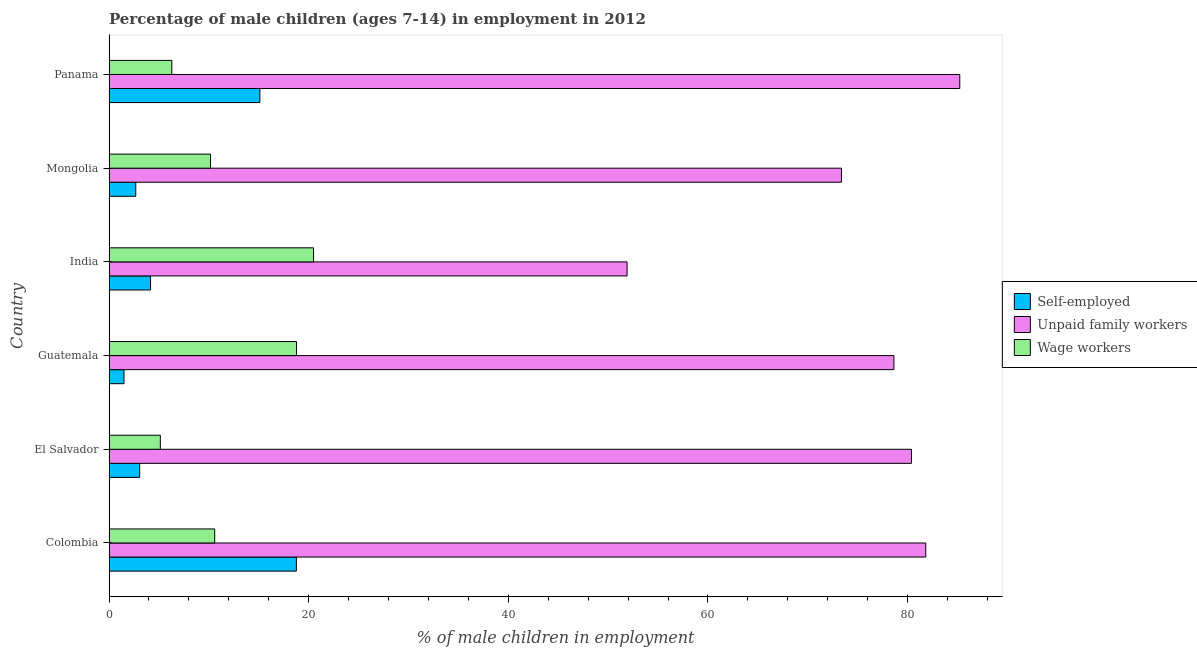How many groups of bars are there?
Provide a succinct answer. 6. Are the number of bars per tick equal to the number of legend labels?
Keep it short and to the point. Yes. How many bars are there on the 4th tick from the top?
Your response must be concise. 3. What is the percentage of children employed as wage workers in Guatemala?
Offer a terse response. 18.78. Across all countries, what is the maximum percentage of children employed as unpaid family workers?
Offer a terse response. 85.23. Across all countries, what is the minimum percentage of children employed as wage workers?
Make the answer very short. 5.14. In which country was the percentage of children employed as wage workers minimum?
Keep it short and to the point. El Salvador. What is the total percentage of children employed as wage workers in the graph?
Ensure brevity in your answer.  71.46. What is the difference between the percentage of children employed as unpaid family workers in Guatemala and that in India?
Your response must be concise. 26.73. What is the difference between the percentage of self employed children in Guatemala and the percentage of children employed as wage workers in India?
Offer a terse response. -18.99. What is the average percentage of children employed as wage workers per country?
Provide a succinct answer. 11.91. What is the difference between the percentage of children employed as unpaid family workers and percentage of self employed children in Panama?
Provide a succinct answer. 70.12. What is the ratio of the percentage of children employed as unpaid family workers in El Salvador to that in Panama?
Give a very brief answer. 0.94. Is the percentage of children employed as unpaid family workers in India less than that in Mongolia?
Provide a succinct answer. Yes. What is the difference between the highest and the second highest percentage of children employed as unpaid family workers?
Provide a short and direct response. 3.41. What is the difference between the highest and the lowest percentage of children employed as unpaid family workers?
Keep it short and to the point. 33.33. In how many countries, is the percentage of self employed children greater than the average percentage of self employed children taken over all countries?
Your response must be concise. 2. What does the 3rd bar from the top in Colombia represents?
Provide a short and direct response. Self-employed. What does the 1st bar from the bottom in Guatemala represents?
Provide a succinct answer. Self-employed. Is it the case that in every country, the sum of the percentage of self employed children and percentage of children employed as unpaid family workers is greater than the percentage of children employed as wage workers?
Ensure brevity in your answer.  Yes. How many bars are there?
Give a very brief answer. 18. What is the difference between two consecutive major ticks on the X-axis?
Offer a terse response. 20. Does the graph contain any zero values?
Provide a short and direct response. No. Where does the legend appear in the graph?
Provide a short and direct response. Center right. How many legend labels are there?
Your response must be concise. 3. What is the title of the graph?
Offer a terse response. Percentage of male children (ages 7-14) in employment in 2012. What is the label or title of the X-axis?
Give a very brief answer. % of male children in employment. What is the % of male children in employment of Self-employed in Colombia?
Your response must be concise. 18.77. What is the % of male children in employment in Unpaid family workers in Colombia?
Your answer should be very brief. 81.82. What is the % of male children in employment in Wage workers in Colombia?
Provide a short and direct response. 10.59. What is the % of male children in employment of Self-employed in El Salvador?
Your answer should be very brief. 3.07. What is the % of male children in employment of Unpaid family workers in El Salvador?
Provide a succinct answer. 80.39. What is the % of male children in employment in Wage workers in El Salvador?
Give a very brief answer. 5.14. What is the % of male children in employment of Self-employed in Guatemala?
Offer a very short reply. 1.5. What is the % of male children in employment of Unpaid family workers in Guatemala?
Ensure brevity in your answer.  78.63. What is the % of male children in employment of Wage workers in Guatemala?
Offer a terse response. 18.78. What is the % of male children in employment in Self-employed in India?
Offer a terse response. 4.16. What is the % of male children in employment of Unpaid family workers in India?
Provide a succinct answer. 51.9. What is the % of male children in employment of Wage workers in India?
Your response must be concise. 20.49. What is the % of male children in employment of Self-employed in Mongolia?
Make the answer very short. 2.68. What is the % of male children in employment of Unpaid family workers in Mongolia?
Your answer should be compact. 73.38. What is the % of male children in employment in Wage workers in Mongolia?
Ensure brevity in your answer.  10.17. What is the % of male children in employment in Self-employed in Panama?
Your answer should be compact. 15.11. What is the % of male children in employment of Unpaid family workers in Panama?
Give a very brief answer. 85.23. What is the % of male children in employment in Wage workers in Panama?
Your response must be concise. 6.29. Across all countries, what is the maximum % of male children in employment of Self-employed?
Keep it short and to the point. 18.77. Across all countries, what is the maximum % of male children in employment in Unpaid family workers?
Offer a very short reply. 85.23. Across all countries, what is the maximum % of male children in employment of Wage workers?
Your response must be concise. 20.49. Across all countries, what is the minimum % of male children in employment of Unpaid family workers?
Offer a terse response. 51.9. Across all countries, what is the minimum % of male children in employment in Wage workers?
Your answer should be very brief. 5.14. What is the total % of male children in employment of Self-employed in the graph?
Offer a terse response. 45.29. What is the total % of male children in employment of Unpaid family workers in the graph?
Your answer should be compact. 451.35. What is the total % of male children in employment of Wage workers in the graph?
Your response must be concise. 71.46. What is the difference between the % of male children in employment of Self-employed in Colombia and that in El Salvador?
Ensure brevity in your answer.  15.7. What is the difference between the % of male children in employment of Unpaid family workers in Colombia and that in El Salvador?
Your answer should be very brief. 1.43. What is the difference between the % of male children in employment in Wage workers in Colombia and that in El Salvador?
Your response must be concise. 5.45. What is the difference between the % of male children in employment of Self-employed in Colombia and that in Guatemala?
Provide a short and direct response. 17.27. What is the difference between the % of male children in employment of Unpaid family workers in Colombia and that in Guatemala?
Provide a short and direct response. 3.19. What is the difference between the % of male children in employment of Wage workers in Colombia and that in Guatemala?
Provide a succinct answer. -8.19. What is the difference between the % of male children in employment in Self-employed in Colombia and that in India?
Ensure brevity in your answer.  14.61. What is the difference between the % of male children in employment of Unpaid family workers in Colombia and that in India?
Offer a terse response. 29.92. What is the difference between the % of male children in employment in Wage workers in Colombia and that in India?
Your answer should be compact. -9.9. What is the difference between the % of male children in employment in Self-employed in Colombia and that in Mongolia?
Provide a succinct answer. 16.09. What is the difference between the % of male children in employment of Unpaid family workers in Colombia and that in Mongolia?
Your answer should be compact. 8.44. What is the difference between the % of male children in employment of Wage workers in Colombia and that in Mongolia?
Your answer should be very brief. 0.42. What is the difference between the % of male children in employment of Self-employed in Colombia and that in Panama?
Give a very brief answer. 3.66. What is the difference between the % of male children in employment of Unpaid family workers in Colombia and that in Panama?
Offer a very short reply. -3.41. What is the difference between the % of male children in employment of Self-employed in El Salvador and that in Guatemala?
Provide a succinct answer. 1.57. What is the difference between the % of male children in employment in Unpaid family workers in El Salvador and that in Guatemala?
Give a very brief answer. 1.76. What is the difference between the % of male children in employment in Wage workers in El Salvador and that in Guatemala?
Give a very brief answer. -13.64. What is the difference between the % of male children in employment of Self-employed in El Salvador and that in India?
Your answer should be compact. -1.09. What is the difference between the % of male children in employment in Unpaid family workers in El Salvador and that in India?
Offer a very short reply. 28.49. What is the difference between the % of male children in employment of Wage workers in El Salvador and that in India?
Ensure brevity in your answer.  -15.35. What is the difference between the % of male children in employment of Self-employed in El Salvador and that in Mongolia?
Make the answer very short. 0.39. What is the difference between the % of male children in employment in Unpaid family workers in El Salvador and that in Mongolia?
Offer a terse response. 7.01. What is the difference between the % of male children in employment in Wage workers in El Salvador and that in Mongolia?
Provide a short and direct response. -5.03. What is the difference between the % of male children in employment of Self-employed in El Salvador and that in Panama?
Ensure brevity in your answer.  -12.04. What is the difference between the % of male children in employment in Unpaid family workers in El Salvador and that in Panama?
Your answer should be compact. -4.84. What is the difference between the % of male children in employment in Wage workers in El Salvador and that in Panama?
Provide a succinct answer. -1.15. What is the difference between the % of male children in employment in Self-employed in Guatemala and that in India?
Your answer should be compact. -2.66. What is the difference between the % of male children in employment of Unpaid family workers in Guatemala and that in India?
Provide a succinct answer. 26.73. What is the difference between the % of male children in employment in Wage workers in Guatemala and that in India?
Your response must be concise. -1.71. What is the difference between the % of male children in employment of Self-employed in Guatemala and that in Mongolia?
Give a very brief answer. -1.18. What is the difference between the % of male children in employment in Unpaid family workers in Guatemala and that in Mongolia?
Give a very brief answer. 5.25. What is the difference between the % of male children in employment of Wage workers in Guatemala and that in Mongolia?
Provide a succinct answer. 8.61. What is the difference between the % of male children in employment of Self-employed in Guatemala and that in Panama?
Ensure brevity in your answer.  -13.61. What is the difference between the % of male children in employment in Wage workers in Guatemala and that in Panama?
Keep it short and to the point. 12.49. What is the difference between the % of male children in employment of Self-employed in India and that in Mongolia?
Give a very brief answer. 1.48. What is the difference between the % of male children in employment in Unpaid family workers in India and that in Mongolia?
Your answer should be very brief. -21.48. What is the difference between the % of male children in employment in Wage workers in India and that in Mongolia?
Keep it short and to the point. 10.32. What is the difference between the % of male children in employment of Self-employed in India and that in Panama?
Make the answer very short. -10.95. What is the difference between the % of male children in employment in Unpaid family workers in India and that in Panama?
Offer a terse response. -33.33. What is the difference between the % of male children in employment in Wage workers in India and that in Panama?
Offer a terse response. 14.2. What is the difference between the % of male children in employment in Self-employed in Mongolia and that in Panama?
Provide a succinct answer. -12.43. What is the difference between the % of male children in employment of Unpaid family workers in Mongolia and that in Panama?
Your response must be concise. -11.85. What is the difference between the % of male children in employment in Wage workers in Mongolia and that in Panama?
Your answer should be compact. 3.88. What is the difference between the % of male children in employment of Self-employed in Colombia and the % of male children in employment of Unpaid family workers in El Salvador?
Offer a very short reply. -61.62. What is the difference between the % of male children in employment in Self-employed in Colombia and the % of male children in employment in Wage workers in El Salvador?
Keep it short and to the point. 13.63. What is the difference between the % of male children in employment of Unpaid family workers in Colombia and the % of male children in employment of Wage workers in El Salvador?
Offer a very short reply. 76.68. What is the difference between the % of male children in employment of Self-employed in Colombia and the % of male children in employment of Unpaid family workers in Guatemala?
Your answer should be very brief. -59.86. What is the difference between the % of male children in employment in Self-employed in Colombia and the % of male children in employment in Wage workers in Guatemala?
Make the answer very short. -0.01. What is the difference between the % of male children in employment in Unpaid family workers in Colombia and the % of male children in employment in Wage workers in Guatemala?
Provide a succinct answer. 63.04. What is the difference between the % of male children in employment in Self-employed in Colombia and the % of male children in employment in Unpaid family workers in India?
Keep it short and to the point. -33.13. What is the difference between the % of male children in employment of Self-employed in Colombia and the % of male children in employment of Wage workers in India?
Your answer should be very brief. -1.72. What is the difference between the % of male children in employment in Unpaid family workers in Colombia and the % of male children in employment in Wage workers in India?
Make the answer very short. 61.33. What is the difference between the % of male children in employment in Self-employed in Colombia and the % of male children in employment in Unpaid family workers in Mongolia?
Offer a terse response. -54.61. What is the difference between the % of male children in employment in Self-employed in Colombia and the % of male children in employment in Wage workers in Mongolia?
Offer a very short reply. 8.6. What is the difference between the % of male children in employment in Unpaid family workers in Colombia and the % of male children in employment in Wage workers in Mongolia?
Give a very brief answer. 71.65. What is the difference between the % of male children in employment of Self-employed in Colombia and the % of male children in employment of Unpaid family workers in Panama?
Provide a short and direct response. -66.46. What is the difference between the % of male children in employment in Self-employed in Colombia and the % of male children in employment in Wage workers in Panama?
Your answer should be very brief. 12.48. What is the difference between the % of male children in employment of Unpaid family workers in Colombia and the % of male children in employment of Wage workers in Panama?
Your answer should be very brief. 75.53. What is the difference between the % of male children in employment of Self-employed in El Salvador and the % of male children in employment of Unpaid family workers in Guatemala?
Ensure brevity in your answer.  -75.56. What is the difference between the % of male children in employment of Self-employed in El Salvador and the % of male children in employment of Wage workers in Guatemala?
Give a very brief answer. -15.71. What is the difference between the % of male children in employment of Unpaid family workers in El Salvador and the % of male children in employment of Wage workers in Guatemala?
Keep it short and to the point. 61.61. What is the difference between the % of male children in employment in Self-employed in El Salvador and the % of male children in employment in Unpaid family workers in India?
Give a very brief answer. -48.83. What is the difference between the % of male children in employment in Self-employed in El Salvador and the % of male children in employment in Wage workers in India?
Make the answer very short. -17.42. What is the difference between the % of male children in employment of Unpaid family workers in El Salvador and the % of male children in employment of Wage workers in India?
Ensure brevity in your answer.  59.9. What is the difference between the % of male children in employment in Self-employed in El Salvador and the % of male children in employment in Unpaid family workers in Mongolia?
Provide a succinct answer. -70.31. What is the difference between the % of male children in employment of Self-employed in El Salvador and the % of male children in employment of Wage workers in Mongolia?
Offer a very short reply. -7.1. What is the difference between the % of male children in employment in Unpaid family workers in El Salvador and the % of male children in employment in Wage workers in Mongolia?
Your answer should be compact. 70.22. What is the difference between the % of male children in employment of Self-employed in El Salvador and the % of male children in employment of Unpaid family workers in Panama?
Your answer should be very brief. -82.16. What is the difference between the % of male children in employment of Self-employed in El Salvador and the % of male children in employment of Wage workers in Panama?
Provide a succinct answer. -3.22. What is the difference between the % of male children in employment of Unpaid family workers in El Salvador and the % of male children in employment of Wage workers in Panama?
Provide a succinct answer. 74.1. What is the difference between the % of male children in employment in Self-employed in Guatemala and the % of male children in employment in Unpaid family workers in India?
Your answer should be very brief. -50.4. What is the difference between the % of male children in employment in Self-employed in Guatemala and the % of male children in employment in Wage workers in India?
Provide a succinct answer. -18.99. What is the difference between the % of male children in employment of Unpaid family workers in Guatemala and the % of male children in employment of Wage workers in India?
Your answer should be very brief. 58.14. What is the difference between the % of male children in employment of Self-employed in Guatemala and the % of male children in employment of Unpaid family workers in Mongolia?
Your answer should be compact. -71.88. What is the difference between the % of male children in employment of Self-employed in Guatemala and the % of male children in employment of Wage workers in Mongolia?
Your answer should be very brief. -8.67. What is the difference between the % of male children in employment in Unpaid family workers in Guatemala and the % of male children in employment in Wage workers in Mongolia?
Make the answer very short. 68.46. What is the difference between the % of male children in employment in Self-employed in Guatemala and the % of male children in employment in Unpaid family workers in Panama?
Make the answer very short. -83.73. What is the difference between the % of male children in employment in Self-employed in Guatemala and the % of male children in employment in Wage workers in Panama?
Your answer should be very brief. -4.79. What is the difference between the % of male children in employment in Unpaid family workers in Guatemala and the % of male children in employment in Wage workers in Panama?
Provide a short and direct response. 72.34. What is the difference between the % of male children in employment of Self-employed in India and the % of male children in employment of Unpaid family workers in Mongolia?
Keep it short and to the point. -69.22. What is the difference between the % of male children in employment in Self-employed in India and the % of male children in employment in Wage workers in Mongolia?
Offer a terse response. -6.01. What is the difference between the % of male children in employment in Unpaid family workers in India and the % of male children in employment in Wage workers in Mongolia?
Your answer should be very brief. 41.73. What is the difference between the % of male children in employment of Self-employed in India and the % of male children in employment of Unpaid family workers in Panama?
Make the answer very short. -81.07. What is the difference between the % of male children in employment of Self-employed in India and the % of male children in employment of Wage workers in Panama?
Provide a succinct answer. -2.13. What is the difference between the % of male children in employment of Unpaid family workers in India and the % of male children in employment of Wage workers in Panama?
Offer a terse response. 45.61. What is the difference between the % of male children in employment of Self-employed in Mongolia and the % of male children in employment of Unpaid family workers in Panama?
Your answer should be very brief. -82.55. What is the difference between the % of male children in employment of Self-employed in Mongolia and the % of male children in employment of Wage workers in Panama?
Give a very brief answer. -3.61. What is the difference between the % of male children in employment in Unpaid family workers in Mongolia and the % of male children in employment in Wage workers in Panama?
Provide a succinct answer. 67.09. What is the average % of male children in employment of Self-employed per country?
Provide a succinct answer. 7.55. What is the average % of male children in employment in Unpaid family workers per country?
Provide a succinct answer. 75.22. What is the average % of male children in employment in Wage workers per country?
Keep it short and to the point. 11.91. What is the difference between the % of male children in employment of Self-employed and % of male children in employment of Unpaid family workers in Colombia?
Offer a very short reply. -63.05. What is the difference between the % of male children in employment in Self-employed and % of male children in employment in Wage workers in Colombia?
Ensure brevity in your answer.  8.18. What is the difference between the % of male children in employment of Unpaid family workers and % of male children in employment of Wage workers in Colombia?
Offer a very short reply. 71.23. What is the difference between the % of male children in employment of Self-employed and % of male children in employment of Unpaid family workers in El Salvador?
Make the answer very short. -77.32. What is the difference between the % of male children in employment in Self-employed and % of male children in employment in Wage workers in El Salvador?
Offer a terse response. -2.07. What is the difference between the % of male children in employment in Unpaid family workers and % of male children in employment in Wage workers in El Salvador?
Provide a succinct answer. 75.25. What is the difference between the % of male children in employment of Self-employed and % of male children in employment of Unpaid family workers in Guatemala?
Offer a terse response. -77.13. What is the difference between the % of male children in employment of Self-employed and % of male children in employment of Wage workers in Guatemala?
Offer a very short reply. -17.28. What is the difference between the % of male children in employment in Unpaid family workers and % of male children in employment in Wage workers in Guatemala?
Provide a succinct answer. 59.85. What is the difference between the % of male children in employment in Self-employed and % of male children in employment in Unpaid family workers in India?
Provide a short and direct response. -47.74. What is the difference between the % of male children in employment in Self-employed and % of male children in employment in Wage workers in India?
Offer a very short reply. -16.33. What is the difference between the % of male children in employment in Unpaid family workers and % of male children in employment in Wage workers in India?
Offer a very short reply. 31.41. What is the difference between the % of male children in employment in Self-employed and % of male children in employment in Unpaid family workers in Mongolia?
Ensure brevity in your answer.  -70.7. What is the difference between the % of male children in employment of Self-employed and % of male children in employment of Wage workers in Mongolia?
Offer a very short reply. -7.49. What is the difference between the % of male children in employment of Unpaid family workers and % of male children in employment of Wage workers in Mongolia?
Your answer should be very brief. 63.21. What is the difference between the % of male children in employment in Self-employed and % of male children in employment in Unpaid family workers in Panama?
Provide a succinct answer. -70.12. What is the difference between the % of male children in employment in Self-employed and % of male children in employment in Wage workers in Panama?
Your response must be concise. 8.82. What is the difference between the % of male children in employment of Unpaid family workers and % of male children in employment of Wage workers in Panama?
Ensure brevity in your answer.  78.94. What is the ratio of the % of male children in employment in Self-employed in Colombia to that in El Salvador?
Offer a very short reply. 6.11. What is the ratio of the % of male children in employment in Unpaid family workers in Colombia to that in El Salvador?
Make the answer very short. 1.02. What is the ratio of the % of male children in employment of Wage workers in Colombia to that in El Salvador?
Provide a short and direct response. 2.06. What is the ratio of the % of male children in employment of Self-employed in Colombia to that in Guatemala?
Keep it short and to the point. 12.51. What is the ratio of the % of male children in employment in Unpaid family workers in Colombia to that in Guatemala?
Ensure brevity in your answer.  1.04. What is the ratio of the % of male children in employment in Wage workers in Colombia to that in Guatemala?
Offer a terse response. 0.56. What is the ratio of the % of male children in employment in Self-employed in Colombia to that in India?
Offer a very short reply. 4.51. What is the ratio of the % of male children in employment in Unpaid family workers in Colombia to that in India?
Your answer should be very brief. 1.58. What is the ratio of the % of male children in employment of Wage workers in Colombia to that in India?
Offer a very short reply. 0.52. What is the ratio of the % of male children in employment in Self-employed in Colombia to that in Mongolia?
Your answer should be very brief. 7. What is the ratio of the % of male children in employment in Unpaid family workers in Colombia to that in Mongolia?
Your answer should be compact. 1.11. What is the ratio of the % of male children in employment of Wage workers in Colombia to that in Mongolia?
Your answer should be compact. 1.04. What is the ratio of the % of male children in employment of Self-employed in Colombia to that in Panama?
Offer a very short reply. 1.24. What is the ratio of the % of male children in employment in Wage workers in Colombia to that in Panama?
Offer a terse response. 1.68. What is the ratio of the % of male children in employment in Self-employed in El Salvador to that in Guatemala?
Offer a terse response. 2.05. What is the ratio of the % of male children in employment of Unpaid family workers in El Salvador to that in Guatemala?
Keep it short and to the point. 1.02. What is the ratio of the % of male children in employment of Wage workers in El Salvador to that in Guatemala?
Give a very brief answer. 0.27. What is the ratio of the % of male children in employment in Self-employed in El Salvador to that in India?
Provide a succinct answer. 0.74. What is the ratio of the % of male children in employment in Unpaid family workers in El Salvador to that in India?
Make the answer very short. 1.55. What is the ratio of the % of male children in employment in Wage workers in El Salvador to that in India?
Your answer should be compact. 0.25. What is the ratio of the % of male children in employment of Self-employed in El Salvador to that in Mongolia?
Keep it short and to the point. 1.15. What is the ratio of the % of male children in employment in Unpaid family workers in El Salvador to that in Mongolia?
Provide a succinct answer. 1.1. What is the ratio of the % of male children in employment in Wage workers in El Salvador to that in Mongolia?
Provide a short and direct response. 0.51. What is the ratio of the % of male children in employment in Self-employed in El Salvador to that in Panama?
Provide a succinct answer. 0.2. What is the ratio of the % of male children in employment of Unpaid family workers in El Salvador to that in Panama?
Your response must be concise. 0.94. What is the ratio of the % of male children in employment in Wage workers in El Salvador to that in Panama?
Provide a succinct answer. 0.82. What is the ratio of the % of male children in employment of Self-employed in Guatemala to that in India?
Your answer should be very brief. 0.36. What is the ratio of the % of male children in employment of Unpaid family workers in Guatemala to that in India?
Make the answer very short. 1.51. What is the ratio of the % of male children in employment of Wage workers in Guatemala to that in India?
Provide a short and direct response. 0.92. What is the ratio of the % of male children in employment in Self-employed in Guatemala to that in Mongolia?
Your answer should be very brief. 0.56. What is the ratio of the % of male children in employment in Unpaid family workers in Guatemala to that in Mongolia?
Offer a terse response. 1.07. What is the ratio of the % of male children in employment in Wage workers in Guatemala to that in Mongolia?
Your answer should be very brief. 1.85. What is the ratio of the % of male children in employment of Self-employed in Guatemala to that in Panama?
Keep it short and to the point. 0.1. What is the ratio of the % of male children in employment of Unpaid family workers in Guatemala to that in Panama?
Your answer should be compact. 0.92. What is the ratio of the % of male children in employment of Wage workers in Guatemala to that in Panama?
Make the answer very short. 2.99. What is the ratio of the % of male children in employment of Self-employed in India to that in Mongolia?
Give a very brief answer. 1.55. What is the ratio of the % of male children in employment in Unpaid family workers in India to that in Mongolia?
Make the answer very short. 0.71. What is the ratio of the % of male children in employment of Wage workers in India to that in Mongolia?
Your response must be concise. 2.01. What is the ratio of the % of male children in employment of Self-employed in India to that in Panama?
Provide a succinct answer. 0.28. What is the ratio of the % of male children in employment of Unpaid family workers in India to that in Panama?
Your answer should be very brief. 0.61. What is the ratio of the % of male children in employment in Wage workers in India to that in Panama?
Your answer should be very brief. 3.26. What is the ratio of the % of male children in employment in Self-employed in Mongolia to that in Panama?
Provide a short and direct response. 0.18. What is the ratio of the % of male children in employment of Unpaid family workers in Mongolia to that in Panama?
Offer a very short reply. 0.86. What is the ratio of the % of male children in employment in Wage workers in Mongolia to that in Panama?
Provide a short and direct response. 1.62. What is the difference between the highest and the second highest % of male children in employment in Self-employed?
Ensure brevity in your answer.  3.66. What is the difference between the highest and the second highest % of male children in employment in Unpaid family workers?
Your response must be concise. 3.41. What is the difference between the highest and the second highest % of male children in employment of Wage workers?
Your response must be concise. 1.71. What is the difference between the highest and the lowest % of male children in employment of Self-employed?
Offer a very short reply. 17.27. What is the difference between the highest and the lowest % of male children in employment of Unpaid family workers?
Offer a very short reply. 33.33. What is the difference between the highest and the lowest % of male children in employment in Wage workers?
Your answer should be compact. 15.35. 